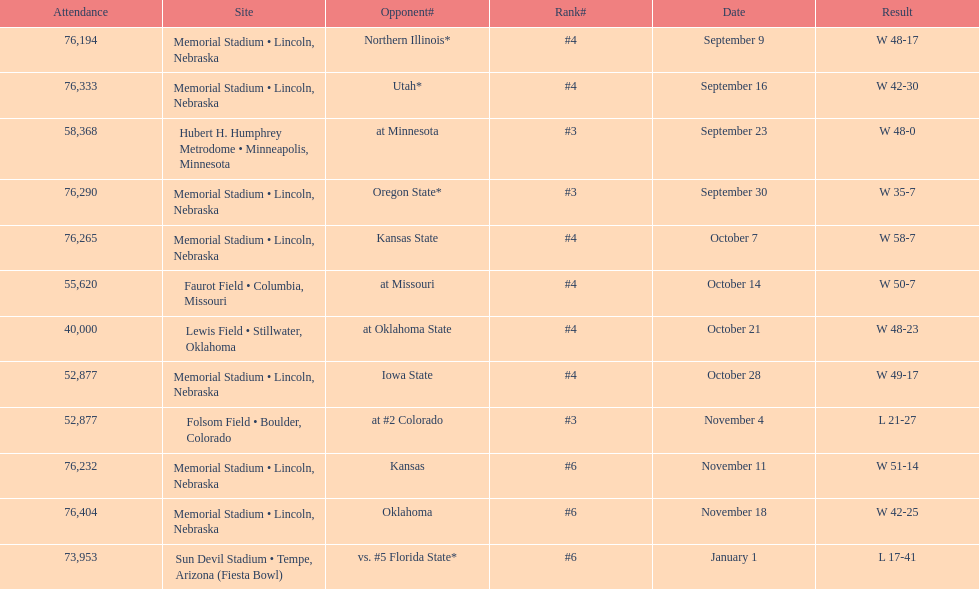On average how many times was w listed as the result? 10. Would you mind parsing the complete table? {'header': ['Attendance', 'Site', 'Opponent#', 'Rank#', 'Date', 'Result'], 'rows': [['76,194', 'Memorial Stadium • Lincoln, Nebraska', 'Northern Illinois*', '#4', 'September 9', 'W\xa048-17'], ['76,333', 'Memorial Stadium • Lincoln, Nebraska', 'Utah*', '#4', 'September 16', 'W\xa042-30'], ['58,368', 'Hubert H. Humphrey Metrodome • Minneapolis, Minnesota', 'at\xa0Minnesota', '#3', 'September 23', 'W\xa048-0'], ['76,290', 'Memorial Stadium • Lincoln, Nebraska', 'Oregon State*', '#3', 'September 30', 'W\xa035-7'], ['76,265', 'Memorial Stadium • Lincoln, Nebraska', 'Kansas State', '#4', 'October 7', 'W\xa058-7'], ['55,620', 'Faurot Field • Columbia, Missouri', 'at\xa0Missouri', '#4', 'October 14', 'W\xa050-7'], ['40,000', 'Lewis Field • Stillwater, Oklahoma', 'at\xa0Oklahoma State', '#4', 'October 21', 'W\xa048-23'], ['52,877', 'Memorial Stadium • Lincoln, Nebraska', 'Iowa State', '#4', 'October 28', 'W\xa049-17'], ['52,877', 'Folsom Field • Boulder, Colorado', 'at\xa0#2\xa0Colorado', '#3', 'November 4', 'L\xa021-27'], ['76,232', 'Memorial Stadium • Lincoln, Nebraska', 'Kansas', '#6', 'November 11', 'W\xa051-14'], ['76,404', 'Memorial Stadium • Lincoln, Nebraska', 'Oklahoma', '#6', 'November 18', 'W\xa042-25'], ['73,953', 'Sun Devil Stadium • Tempe, Arizona (Fiesta Bowl)', 'vs.\xa0#5\xa0Florida State*', '#6', 'January 1', 'L\xa017-41']]} 